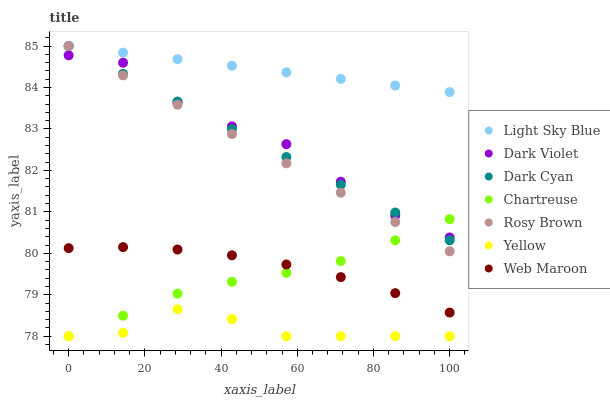Does Yellow have the minimum area under the curve?
Answer yes or no. Yes. Does Light Sky Blue have the maximum area under the curve?
Answer yes or no. Yes. Does Web Maroon have the minimum area under the curve?
Answer yes or no. No. Does Web Maroon have the maximum area under the curve?
Answer yes or no. No. Is Dark Cyan the smoothest?
Answer yes or no. Yes. Is Dark Violet the roughest?
Answer yes or no. Yes. Is Web Maroon the smoothest?
Answer yes or no. No. Is Web Maroon the roughest?
Answer yes or no. No. Does Yellow have the lowest value?
Answer yes or no. Yes. Does Web Maroon have the lowest value?
Answer yes or no. No. Does Dark Cyan have the highest value?
Answer yes or no. Yes. Does Web Maroon have the highest value?
Answer yes or no. No. Is Yellow less than Web Maroon?
Answer yes or no. Yes. Is Web Maroon greater than Yellow?
Answer yes or no. Yes. Does Dark Cyan intersect Rosy Brown?
Answer yes or no. Yes. Is Dark Cyan less than Rosy Brown?
Answer yes or no. No. Is Dark Cyan greater than Rosy Brown?
Answer yes or no. No. Does Yellow intersect Web Maroon?
Answer yes or no. No. 